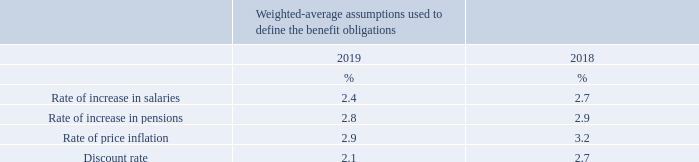7 Employee benefits
Pension plans
The Company is accounting for pension costs in accordance with International Accounting Standard 19.
The disclosures shown here are in respect of the Company’s defined benefit obligations. Other plans operated by the Company were defined contribution plans.
The total expense relating to the Company’s defined contribution pension plans in the current year was £0.7m (2018: £0.6m).
At 31st December 2019 the post-retirement mortality assumptions in respect of the Company Defined Benefit Scheme follows 85%/96% (male/female) of SAPS S2, CMI 2017 projections with a long term trend of 1.25% p.a. At 31st December 2018 the postretirement mortality assumptions in respect of the Company Defined Benefit Scheme follows 85% of SAPS S2 Light base table for males and 96% of SAPS S2 base table for females with CMI Core Projection Model 2016 improvements commencing in 2007, subject to a 1.25% p.a. long-term trend. These assumptions are regularly reviewed in light of scheme-specific experience and more widely available statistics.
The financial assumptions used at 31st December were:
The assumptions used by the actuary are the best estimates chosen from a range of possible actuarial assumptions, which due to the timescale covered, may not necessarily be borne out in practice.
Why are the post-retirement mortality assumptions regularly reviewed? In light of scheme-specific experience and more widely available statistics. What is the Company accounting for pension costs in accordance to? With international accounting standard 19. What were the financial assumptions used at 31st December? Rate of increase in salaries, rate of increase in pensions, rate of price inflation, discount rate. In which year was the discount rate larger? 2.7%>2.1%
Answer: 2018. What was the absolute percentage change in the rate of price inflation from 2018 to 2019?
Answer scale should be: percent. 2.9%-3.2%
Answer: -0.3. What was the absolute percentage change in the discount rate from 2018 to 2019?
Answer scale should be: percent. 2.1%-2.7%
Answer: -0.6. 